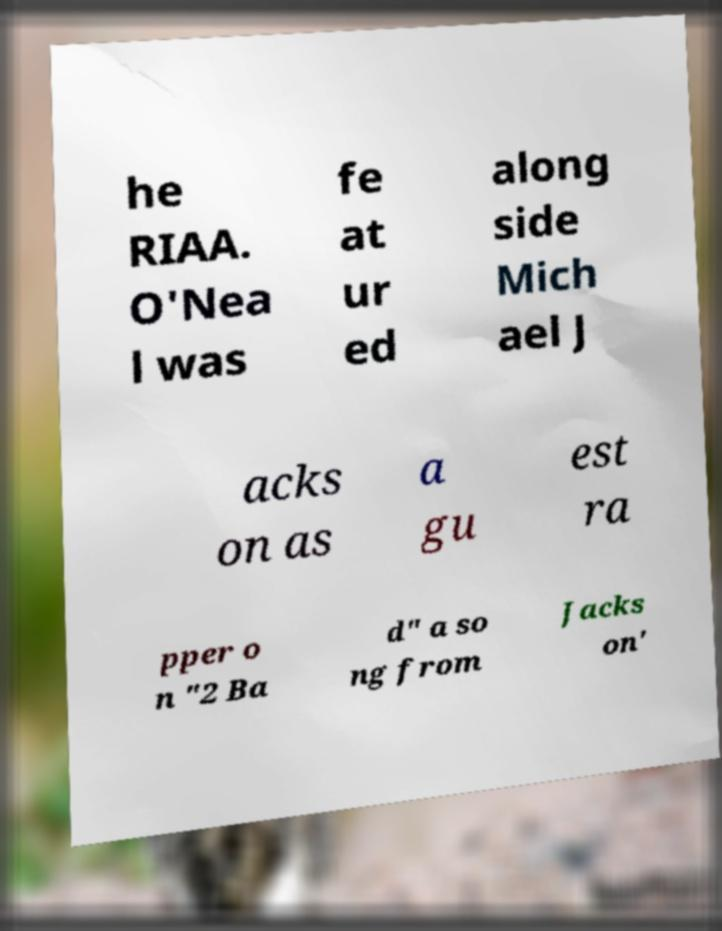Please identify and transcribe the text found in this image. he RIAA. O'Nea l was fe at ur ed along side Mich ael J acks on as a gu est ra pper o n "2 Ba d" a so ng from Jacks on' 